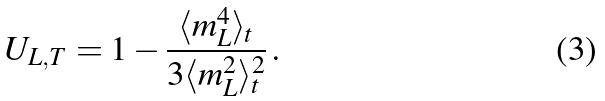Convert formula to latex. <formula><loc_0><loc_0><loc_500><loc_500>U _ { L , T } = 1 - \frac { \langle m _ { L } ^ { 4 } \rangle _ { t } } { 3 \langle m _ { L } ^ { 2 } \rangle _ { t } ^ { 2 } } \, .</formula> 